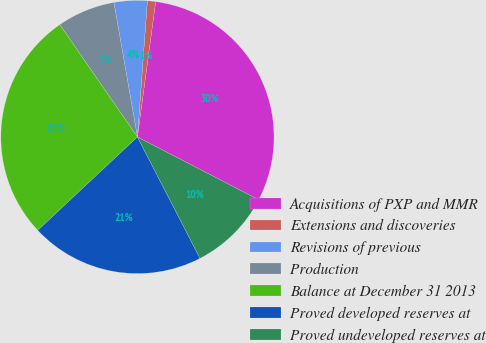Convert chart. <chart><loc_0><loc_0><loc_500><loc_500><pie_chart><fcel>Acquisitions of PXP and MMR<fcel>Extensions and discoveries<fcel>Revisions of previous<fcel>Production<fcel>Balance at December 31 2013<fcel>Proved developed reserves at<fcel>Proved undeveloped reserves at<nl><fcel>30.47%<fcel>0.97%<fcel>3.92%<fcel>6.87%<fcel>27.35%<fcel>20.59%<fcel>9.82%<nl></chart> 